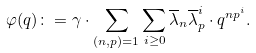<formula> <loc_0><loc_0><loc_500><loc_500>\varphi ( q ) \colon = \gamma \cdot \sum _ { ( n , p ) = 1 } \sum _ { i \geq 0 } \overline { \lambda } _ { n } \overline { \lambda } _ { p } ^ { i } \cdot q ^ { n p ^ { i } } .</formula> 